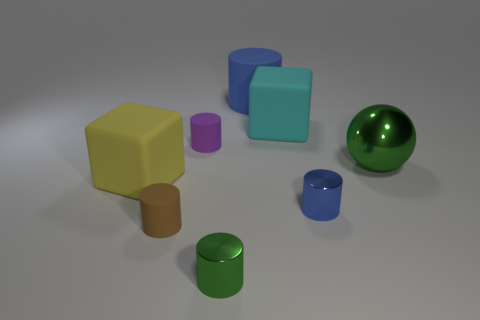There is a green metal thing that is in front of the blue metal cylinder; is its size the same as the large green sphere?
Keep it short and to the point. No. Is the number of big yellow things left of the small green metallic thing less than the number of tiny blue objects?
Give a very brief answer. No. What is the material of the cylinder that is the same size as the metallic sphere?
Provide a short and direct response. Rubber. How many large objects are either yellow rubber cubes or red rubber objects?
Your response must be concise. 1. What number of objects are either green metallic things that are behind the brown rubber object or cubes that are to the left of the tiny purple matte cylinder?
Offer a terse response. 2. Is the number of blue objects less than the number of gray balls?
Your answer should be compact. No. There is a blue matte thing that is the same size as the yellow thing; what shape is it?
Give a very brief answer. Cylinder. What number of other objects are the same color as the big matte cylinder?
Provide a succinct answer. 1. How many small matte cylinders are there?
Your answer should be compact. 2. What number of objects are both on the left side of the green sphere and in front of the small purple rubber object?
Provide a succinct answer. 4. 